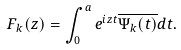Convert formula to latex. <formula><loc_0><loc_0><loc_500><loc_500>F _ { k } ( z ) = \int _ { 0 } ^ { a } e ^ { i z t } \overline { \Psi _ { k } ( t ) } d t .</formula> 